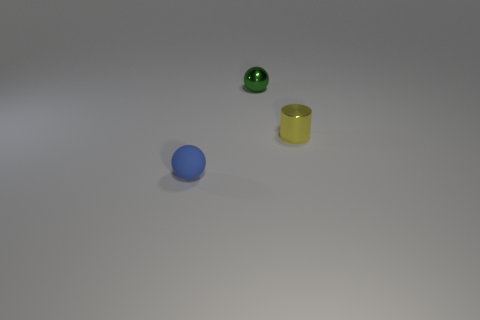Is there any other thing that is the same shape as the small yellow object?
Keep it short and to the point. No. What material is the other green object that is the same shape as the tiny matte thing?
Give a very brief answer. Metal. There is a yellow object that is in front of the green metal object; is its shape the same as the metal thing behind the tiny yellow metallic thing?
Provide a short and direct response. No. The cylinder that is made of the same material as the tiny green sphere is what color?
Provide a succinct answer. Yellow. Does the object on the right side of the green metal object have the same size as the green object to the left of the tiny yellow shiny cylinder?
Your answer should be very brief. Yes. There is a tiny object that is both left of the small yellow metal cylinder and behind the small matte thing; what is its shape?
Offer a terse response. Sphere. Are there any cyan objects that have the same material as the blue object?
Offer a terse response. No. Do the tiny sphere behind the small blue thing and the tiny thing that is to the right of the green shiny sphere have the same material?
Keep it short and to the point. Yes. Are there more big brown rubber balls than spheres?
Offer a very short reply. No. There is a small object behind the tiny metal thing in front of the small shiny thing that is behind the yellow metallic cylinder; what is its color?
Your response must be concise. Green. 